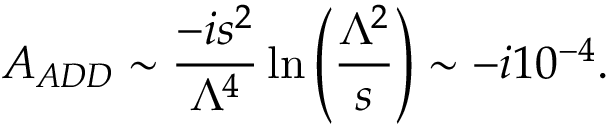<formula> <loc_0><loc_0><loc_500><loc_500>A _ { A D D } \sim \frac { - i s ^ { 2 } } { \Lambda ^ { 4 } } \ln \left ( \frac { \Lambda ^ { 2 } } { s } \right ) \sim - i 1 0 ^ { - 4 } .</formula> 